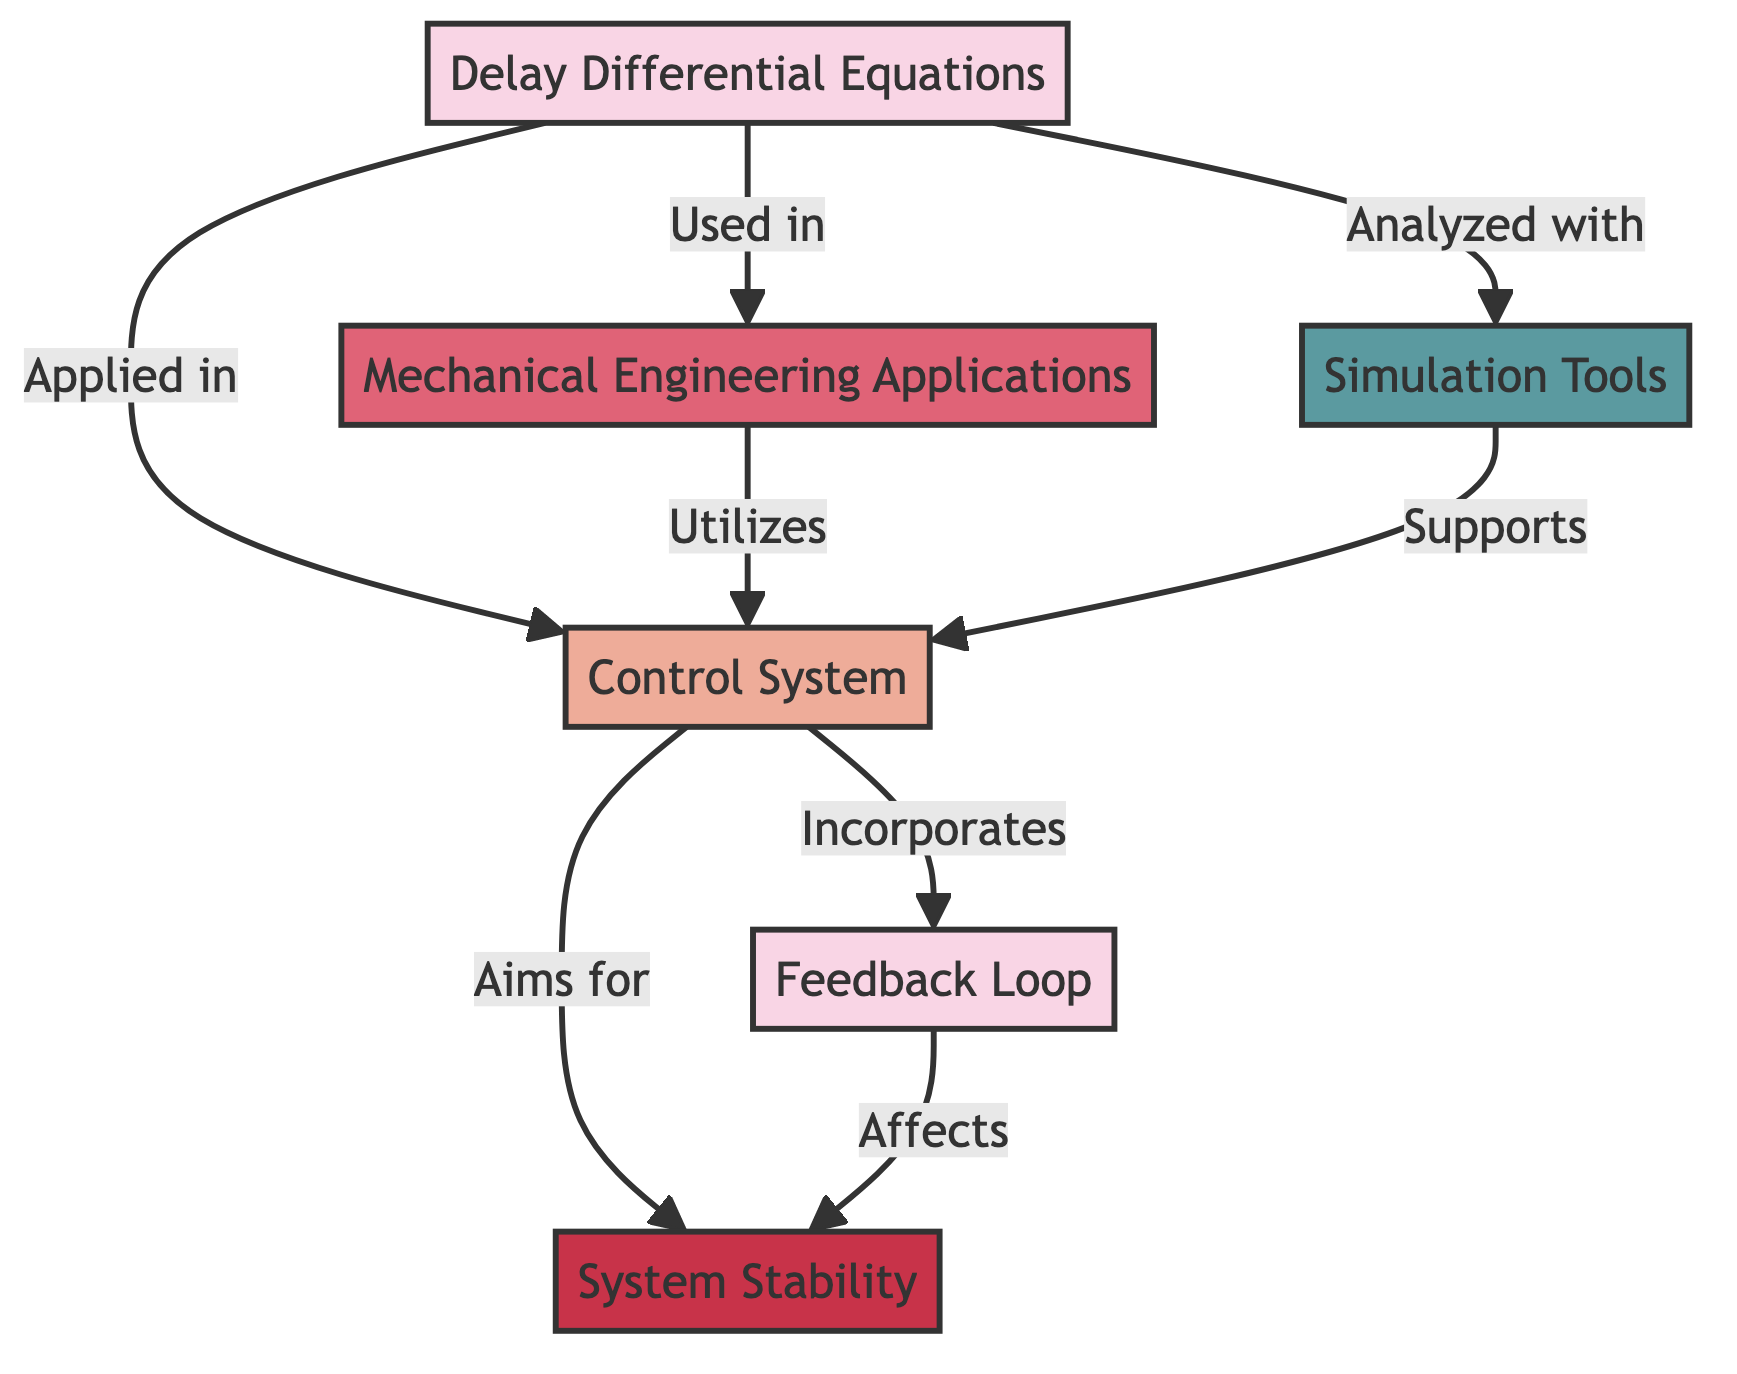What are the elements represented in this diagram? The diagram includes six elements: Delay Differential Equations, Control System, Mechanical Engineering Applications, Feedback Loop, System Stability, and Simulation Tools. Each element represents a unique concept, system, application, property, or resource related to the overall theme.
Answer: Delay Differential Equations, Control System, Mechanical Engineering Applications, Feedback Loop, System Stability, Simulation Tools How many concepts are in the diagram? The diagram contains three concepts: Delay Differential Equations, Feedback Loop, and System Stability. Concepts are typically shown within the diagram as a specific category, indicating their role in the system's analysis.
Answer: Three Which element is used to analyze Delay Differential Equations? The diagram shows Simulation Tools as the element that is used to analyze Delay Differential Equations. An arrow pointing from Delay Differential Equations to Simulation Tools indicates this relationship clearly.
Answer: Simulation Tools What does the Control System aim for according to the diagram? According to the diagram, the Control System aims for System Stability. This aim is represented by a directed edge from the Control System to the System Stability element.
Answer: System Stability How are Mechanical Engineering Applications related to Control Systems? The relationship is that Mechanical Engineering Applications utilize Control Systems, which is depicted by an arrow going from Mechanical Engineering Applications to Control System, indicating that these applications depend on or make use of control systems for their functions.
Answer: Utilizes How does Feedback Loop affect System Stability? The diagram indicates that the Feedback Loop affects System Stability, emphasizing that the interactions within the feedback mechanism play a crucial role in maintaining or improving stability in control systems.
Answer: Affects What is the relationship between Delay Differential Equations and Mechanical Engineering Applications? Delay Differential Equations are used in Mechanical Engineering Applications, which shows a directional edge from Delay Differential Equations pointing towards Mechanical Engineering Applications, implying their applicability and importance in that field.
Answer: Used in Which resource supports the Control System? The diagram specifies that Simulation Tools support the Control System through a directed link from Simulation Tools to Control System, indicating that these tools provide necessary resources for control system analysis and design.
Answer: Simulation Tools 